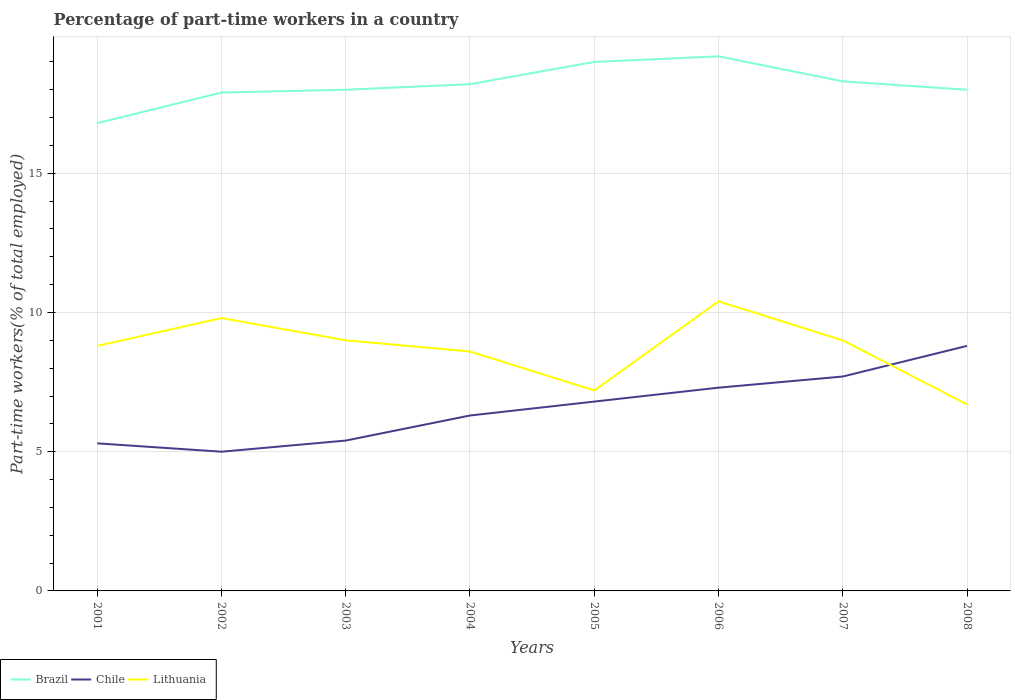Does the line corresponding to Lithuania intersect with the line corresponding to Brazil?
Make the answer very short. No. Is the number of lines equal to the number of legend labels?
Keep it short and to the point. Yes. What is the total percentage of part-time workers in Brazil in the graph?
Your answer should be very brief. 0.7. What is the difference between the highest and the second highest percentage of part-time workers in Chile?
Offer a very short reply. 3.8. What is the difference between the highest and the lowest percentage of part-time workers in Brazil?
Provide a short and direct response. 4. How many lines are there?
Provide a short and direct response. 3. How many years are there in the graph?
Your answer should be compact. 8. Are the values on the major ticks of Y-axis written in scientific E-notation?
Your answer should be very brief. No. Where does the legend appear in the graph?
Offer a terse response. Bottom left. How are the legend labels stacked?
Offer a very short reply. Horizontal. What is the title of the graph?
Offer a terse response. Percentage of part-time workers in a country. Does "Arab World" appear as one of the legend labels in the graph?
Your answer should be compact. No. What is the label or title of the Y-axis?
Your answer should be compact. Part-time workers(% of total employed). What is the Part-time workers(% of total employed) in Brazil in 2001?
Provide a succinct answer. 16.8. What is the Part-time workers(% of total employed) in Chile in 2001?
Make the answer very short. 5.3. What is the Part-time workers(% of total employed) of Lithuania in 2001?
Give a very brief answer. 8.8. What is the Part-time workers(% of total employed) of Brazil in 2002?
Keep it short and to the point. 17.9. What is the Part-time workers(% of total employed) in Lithuania in 2002?
Ensure brevity in your answer.  9.8. What is the Part-time workers(% of total employed) in Brazil in 2003?
Your answer should be compact. 18. What is the Part-time workers(% of total employed) in Chile in 2003?
Provide a short and direct response. 5.4. What is the Part-time workers(% of total employed) of Brazil in 2004?
Keep it short and to the point. 18.2. What is the Part-time workers(% of total employed) of Chile in 2004?
Make the answer very short. 6.3. What is the Part-time workers(% of total employed) of Lithuania in 2004?
Your response must be concise. 8.6. What is the Part-time workers(% of total employed) of Chile in 2005?
Make the answer very short. 6.8. What is the Part-time workers(% of total employed) of Lithuania in 2005?
Make the answer very short. 7.2. What is the Part-time workers(% of total employed) of Brazil in 2006?
Make the answer very short. 19.2. What is the Part-time workers(% of total employed) in Chile in 2006?
Your response must be concise. 7.3. What is the Part-time workers(% of total employed) of Lithuania in 2006?
Offer a terse response. 10.4. What is the Part-time workers(% of total employed) in Brazil in 2007?
Keep it short and to the point. 18.3. What is the Part-time workers(% of total employed) in Chile in 2007?
Offer a terse response. 7.7. What is the Part-time workers(% of total employed) of Chile in 2008?
Ensure brevity in your answer.  8.8. What is the Part-time workers(% of total employed) in Lithuania in 2008?
Provide a succinct answer. 6.7. Across all years, what is the maximum Part-time workers(% of total employed) of Brazil?
Provide a short and direct response. 19.2. Across all years, what is the maximum Part-time workers(% of total employed) in Chile?
Your answer should be very brief. 8.8. Across all years, what is the maximum Part-time workers(% of total employed) in Lithuania?
Provide a short and direct response. 10.4. Across all years, what is the minimum Part-time workers(% of total employed) of Brazil?
Keep it short and to the point. 16.8. Across all years, what is the minimum Part-time workers(% of total employed) in Lithuania?
Your answer should be very brief. 6.7. What is the total Part-time workers(% of total employed) of Brazil in the graph?
Your response must be concise. 145.4. What is the total Part-time workers(% of total employed) in Chile in the graph?
Your answer should be compact. 52.6. What is the total Part-time workers(% of total employed) in Lithuania in the graph?
Keep it short and to the point. 69.5. What is the difference between the Part-time workers(% of total employed) of Brazil in 2001 and that in 2002?
Offer a very short reply. -1.1. What is the difference between the Part-time workers(% of total employed) in Chile in 2001 and that in 2002?
Offer a terse response. 0.3. What is the difference between the Part-time workers(% of total employed) in Lithuania in 2001 and that in 2002?
Make the answer very short. -1. What is the difference between the Part-time workers(% of total employed) of Brazil in 2001 and that in 2003?
Ensure brevity in your answer.  -1.2. What is the difference between the Part-time workers(% of total employed) of Lithuania in 2001 and that in 2003?
Make the answer very short. -0.2. What is the difference between the Part-time workers(% of total employed) in Chile in 2001 and that in 2004?
Your response must be concise. -1. What is the difference between the Part-time workers(% of total employed) in Chile in 2001 and that in 2005?
Make the answer very short. -1.5. What is the difference between the Part-time workers(% of total employed) of Brazil in 2001 and that in 2007?
Your answer should be very brief. -1.5. What is the difference between the Part-time workers(% of total employed) of Chile in 2001 and that in 2007?
Your response must be concise. -2.4. What is the difference between the Part-time workers(% of total employed) of Lithuania in 2001 and that in 2007?
Provide a succinct answer. -0.2. What is the difference between the Part-time workers(% of total employed) in Brazil in 2001 and that in 2008?
Your answer should be compact. -1.2. What is the difference between the Part-time workers(% of total employed) in Chile in 2001 and that in 2008?
Offer a terse response. -3.5. What is the difference between the Part-time workers(% of total employed) of Brazil in 2002 and that in 2003?
Your answer should be very brief. -0.1. What is the difference between the Part-time workers(% of total employed) of Chile in 2002 and that in 2003?
Your response must be concise. -0.4. What is the difference between the Part-time workers(% of total employed) in Brazil in 2002 and that in 2004?
Ensure brevity in your answer.  -0.3. What is the difference between the Part-time workers(% of total employed) of Chile in 2002 and that in 2004?
Keep it short and to the point. -1.3. What is the difference between the Part-time workers(% of total employed) in Lithuania in 2002 and that in 2005?
Your response must be concise. 2.6. What is the difference between the Part-time workers(% of total employed) in Lithuania in 2002 and that in 2006?
Provide a succinct answer. -0.6. What is the difference between the Part-time workers(% of total employed) in Brazil in 2002 and that in 2007?
Offer a very short reply. -0.4. What is the difference between the Part-time workers(% of total employed) in Chile in 2002 and that in 2007?
Offer a very short reply. -2.7. What is the difference between the Part-time workers(% of total employed) in Chile in 2002 and that in 2008?
Keep it short and to the point. -3.8. What is the difference between the Part-time workers(% of total employed) of Chile in 2003 and that in 2005?
Ensure brevity in your answer.  -1.4. What is the difference between the Part-time workers(% of total employed) in Brazil in 2003 and that in 2006?
Provide a succinct answer. -1.2. What is the difference between the Part-time workers(% of total employed) in Chile in 2003 and that in 2006?
Keep it short and to the point. -1.9. What is the difference between the Part-time workers(% of total employed) in Lithuania in 2003 and that in 2006?
Ensure brevity in your answer.  -1.4. What is the difference between the Part-time workers(% of total employed) in Lithuania in 2003 and that in 2007?
Your answer should be compact. 0. What is the difference between the Part-time workers(% of total employed) in Brazil in 2003 and that in 2008?
Offer a very short reply. 0. What is the difference between the Part-time workers(% of total employed) in Brazil in 2004 and that in 2005?
Provide a short and direct response. -0.8. What is the difference between the Part-time workers(% of total employed) in Chile in 2004 and that in 2005?
Provide a succinct answer. -0.5. What is the difference between the Part-time workers(% of total employed) of Lithuania in 2004 and that in 2006?
Offer a very short reply. -1.8. What is the difference between the Part-time workers(% of total employed) of Chile in 2004 and that in 2007?
Your response must be concise. -1.4. What is the difference between the Part-time workers(% of total employed) in Brazil in 2004 and that in 2008?
Your answer should be compact. 0.2. What is the difference between the Part-time workers(% of total employed) in Chile in 2005 and that in 2006?
Offer a very short reply. -0.5. What is the difference between the Part-time workers(% of total employed) in Lithuania in 2005 and that in 2006?
Your response must be concise. -3.2. What is the difference between the Part-time workers(% of total employed) in Lithuania in 2005 and that in 2007?
Offer a terse response. -1.8. What is the difference between the Part-time workers(% of total employed) in Brazil in 2005 and that in 2008?
Provide a short and direct response. 1. What is the difference between the Part-time workers(% of total employed) of Chile in 2005 and that in 2008?
Offer a terse response. -2. What is the difference between the Part-time workers(% of total employed) in Lithuania in 2006 and that in 2007?
Offer a very short reply. 1.4. What is the difference between the Part-time workers(% of total employed) of Brazil in 2001 and the Part-time workers(% of total employed) of Lithuania in 2002?
Ensure brevity in your answer.  7. What is the difference between the Part-time workers(% of total employed) of Chile in 2001 and the Part-time workers(% of total employed) of Lithuania in 2002?
Make the answer very short. -4.5. What is the difference between the Part-time workers(% of total employed) in Brazil in 2001 and the Part-time workers(% of total employed) in Chile in 2004?
Offer a terse response. 10.5. What is the difference between the Part-time workers(% of total employed) in Brazil in 2001 and the Part-time workers(% of total employed) in Lithuania in 2004?
Keep it short and to the point. 8.2. What is the difference between the Part-time workers(% of total employed) of Chile in 2001 and the Part-time workers(% of total employed) of Lithuania in 2004?
Make the answer very short. -3.3. What is the difference between the Part-time workers(% of total employed) in Brazil in 2001 and the Part-time workers(% of total employed) in Chile in 2005?
Your answer should be very brief. 10. What is the difference between the Part-time workers(% of total employed) of Brazil in 2001 and the Part-time workers(% of total employed) of Lithuania in 2005?
Provide a succinct answer. 9.6. What is the difference between the Part-time workers(% of total employed) of Brazil in 2001 and the Part-time workers(% of total employed) of Chile in 2006?
Provide a succinct answer. 9.5. What is the difference between the Part-time workers(% of total employed) of Chile in 2001 and the Part-time workers(% of total employed) of Lithuania in 2006?
Your answer should be compact. -5.1. What is the difference between the Part-time workers(% of total employed) in Chile in 2001 and the Part-time workers(% of total employed) in Lithuania in 2008?
Offer a very short reply. -1.4. What is the difference between the Part-time workers(% of total employed) of Brazil in 2002 and the Part-time workers(% of total employed) of Chile in 2003?
Offer a very short reply. 12.5. What is the difference between the Part-time workers(% of total employed) of Brazil in 2002 and the Part-time workers(% of total employed) of Chile in 2004?
Your response must be concise. 11.6. What is the difference between the Part-time workers(% of total employed) of Chile in 2002 and the Part-time workers(% of total employed) of Lithuania in 2004?
Your response must be concise. -3.6. What is the difference between the Part-time workers(% of total employed) of Brazil in 2002 and the Part-time workers(% of total employed) of Chile in 2005?
Provide a succinct answer. 11.1. What is the difference between the Part-time workers(% of total employed) in Brazil in 2002 and the Part-time workers(% of total employed) in Lithuania in 2005?
Offer a terse response. 10.7. What is the difference between the Part-time workers(% of total employed) in Brazil in 2002 and the Part-time workers(% of total employed) in Chile in 2007?
Make the answer very short. 10.2. What is the difference between the Part-time workers(% of total employed) of Brazil in 2002 and the Part-time workers(% of total employed) of Lithuania in 2008?
Offer a very short reply. 11.2. What is the difference between the Part-time workers(% of total employed) in Brazil in 2003 and the Part-time workers(% of total employed) in Chile in 2004?
Offer a very short reply. 11.7. What is the difference between the Part-time workers(% of total employed) in Chile in 2003 and the Part-time workers(% of total employed) in Lithuania in 2004?
Your answer should be compact. -3.2. What is the difference between the Part-time workers(% of total employed) in Brazil in 2003 and the Part-time workers(% of total employed) in Lithuania in 2006?
Provide a succinct answer. 7.6. What is the difference between the Part-time workers(% of total employed) of Chile in 2003 and the Part-time workers(% of total employed) of Lithuania in 2006?
Provide a short and direct response. -5. What is the difference between the Part-time workers(% of total employed) of Brazil in 2003 and the Part-time workers(% of total employed) of Chile in 2007?
Make the answer very short. 10.3. What is the difference between the Part-time workers(% of total employed) of Brazil in 2003 and the Part-time workers(% of total employed) of Lithuania in 2007?
Your response must be concise. 9. What is the difference between the Part-time workers(% of total employed) of Chile in 2003 and the Part-time workers(% of total employed) of Lithuania in 2007?
Keep it short and to the point. -3.6. What is the difference between the Part-time workers(% of total employed) in Brazil in 2003 and the Part-time workers(% of total employed) in Chile in 2008?
Keep it short and to the point. 9.2. What is the difference between the Part-time workers(% of total employed) of Brazil in 2003 and the Part-time workers(% of total employed) of Lithuania in 2008?
Make the answer very short. 11.3. What is the difference between the Part-time workers(% of total employed) in Chile in 2003 and the Part-time workers(% of total employed) in Lithuania in 2008?
Keep it short and to the point. -1.3. What is the difference between the Part-time workers(% of total employed) in Brazil in 2004 and the Part-time workers(% of total employed) in Lithuania in 2005?
Give a very brief answer. 11. What is the difference between the Part-time workers(% of total employed) in Chile in 2004 and the Part-time workers(% of total employed) in Lithuania in 2005?
Offer a terse response. -0.9. What is the difference between the Part-time workers(% of total employed) in Brazil in 2004 and the Part-time workers(% of total employed) in Lithuania in 2006?
Your answer should be compact. 7.8. What is the difference between the Part-time workers(% of total employed) of Chile in 2004 and the Part-time workers(% of total employed) of Lithuania in 2006?
Provide a short and direct response. -4.1. What is the difference between the Part-time workers(% of total employed) of Brazil in 2004 and the Part-time workers(% of total employed) of Chile in 2007?
Offer a terse response. 10.5. What is the difference between the Part-time workers(% of total employed) in Brazil in 2004 and the Part-time workers(% of total employed) in Lithuania in 2007?
Offer a terse response. 9.2. What is the difference between the Part-time workers(% of total employed) of Brazil in 2004 and the Part-time workers(% of total employed) of Chile in 2008?
Your answer should be very brief. 9.4. What is the difference between the Part-time workers(% of total employed) in Brazil in 2005 and the Part-time workers(% of total employed) in Chile in 2006?
Offer a very short reply. 11.7. What is the difference between the Part-time workers(% of total employed) in Brazil in 2005 and the Part-time workers(% of total employed) in Lithuania in 2006?
Provide a short and direct response. 8.6. What is the difference between the Part-time workers(% of total employed) of Brazil in 2005 and the Part-time workers(% of total employed) of Lithuania in 2007?
Give a very brief answer. 10. What is the difference between the Part-time workers(% of total employed) of Brazil in 2005 and the Part-time workers(% of total employed) of Chile in 2008?
Your answer should be compact. 10.2. What is the difference between the Part-time workers(% of total employed) in Brazil in 2005 and the Part-time workers(% of total employed) in Lithuania in 2008?
Your response must be concise. 12.3. What is the difference between the Part-time workers(% of total employed) of Chile in 2005 and the Part-time workers(% of total employed) of Lithuania in 2008?
Your answer should be very brief. 0.1. What is the difference between the Part-time workers(% of total employed) in Chile in 2006 and the Part-time workers(% of total employed) in Lithuania in 2008?
Ensure brevity in your answer.  0.6. What is the difference between the Part-time workers(% of total employed) in Brazil in 2007 and the Part-time workers(% of total employed) in Chile in 2008?
Your answer should be compact. 9.5. What is the average Part-time workers(% of total employed) of Brazil per year?
Make the answer very short. 18.18. What is the average Part-time workers(% of total employed) in Chile per year?
Offer a very short reply. 6.58. What is the average Part-time workers(% of total employed) of Lithuania per year?
Offer a terse response. 8.69. In the year 2002, what is the difference between the Part-time workers(% of total employed) in Brazil and Part-time workers(% of total employed) in Chile?
Offer a terse response. 12.9. In the year 2002, what is the difference between the Part-time workers(% of total employed) of Brazil and Part-time workers(% of total employed) of Lithuania?
Provide a short and direct response. 8.1. In the year 2003, what is the difference between the Part-time workers(% of total employed) in Brazil and Part-time workers(% of total employed) in Chile?
Your answer should be very brief. 12.6. In the year 2003, what is the difference between the Part-time workers(% of total employed) in Brazil and Part-time workers(% of total employed) in Lithuania?
Your response must be concise. 9. In the year 2004, what is the difference between the Part-time workers(% of total employed) in Brazil and Part-time workers(% of total employed) in Chile?
Your answer should be compact. 11.9. In the year 2005, what is the difference between the Part-time workers(% of total employed) of Brazil and Part-time workers(% of total employed) of Chile?
Provide a succinct answer. 12.2. In the year 2006, what is the difference between the Part-time workers(% of total employed) of Brazil and Part-time workers(% of total employed) of Chile?
Offer a very short reply. 11.9. In the year 2007, what is the difference between the Part-time workers(% of total employed) of Chile and Part-time workers(% of total employed) of Lithuania?
Your response must be concise. -1.3. In the year 2008, what is the difference between the Part-time workers(% of total employed) of Brazil and Part-time workers(% of total employed) of Chile?
Make the answer very short. 9.2. What is the ratio of the Part-time workers(% of total employed) in Brazil in 2001 to that in 2002?
Provide a succinct answer. 0.94. What is the ratio of the Part-time workers(% of total employed) in Chile in 2001 to that in 2002?
Your answer should be very brief. 1.06. What is the ratio of the Part-time workers(% of total employed) in Lithuania in 2001 to that in 2002?
Ensure brevity in your answer.  0.9. What is the ratio of the Part-time workers(% of total employed) in Chile in 2001 to that in 2003?
Provide a succinct answer. 0.98. What is the ratio of the Part-time workers(% of total employed) of Lithuania in 2001 to that in 2003?
Provide a short and direct response. 0.98. What is the ratio of the Part-time workers(% of total employed) in Chile in 2001 to that in 2004?
Make the answer very short. 0.84. What is the ratio of the Part-time workers(% of total employed) in Lithuania in 2001 to that in 2004?
Keep it short and to the point. 1.02. What is the ratio of the Part-time workers(% of total employed) of Brazil in 2001 to that in 2005?
Provide a short and direct response. 0.88. What is the ratio of the Part-time workers(% of total employed) of Chile in 2001 to that in 2005?
Give a very brief answer. 0.78. What is the ratio of the Part-time workers(% of total employed) in Lithuania in 2001 to that in 2005?
Give a very brief answer. 1.22. What is the ratio of the Part-time workers(% of total employed) of Chile in 2001 to that in 2006?
Your response must be concise. 0.73. What is the ratio of the Part-time workers(% of total employed) of Lithuania in 2001 to that in 2006?
Make the answer very short. 0.85. What is the ratio of the Part-time workers(% of total employed) in Brazil in 2001 to that in 2007?
Make the answer very short. 0.92. What is the ratio of the Part-time workers(% of total employed) in Chile in 2001 to that in 2007?
Offer a terse response. 0.69. What is the ratio of the Part-time workers(% of total employed) of Lithuania in 2001 to that in 2007?
Provide a short and direct response. 0.98. What is the ratio of the Part-time workers(% of total employed) of Chile in 2001 to that in 2008?
Make the answer very short. 0.6. What is the ratio of the Part-time workers(% of total employed) of Lithuania in 2001 to that in 2008?
Ensure brevity in your answer.  1.31. What is the ratio of the Part-time workers(% of total employed) in Brazil in 2002 to that in 2003?
Make the answer very short. 0.99. What is the ratio of the Part-time workers(% of total employed) of Chile in 2002 to that in 2003?
Offer a terse response. 0.93. What is the ratio of the Part-time workers(% of total employed) in Lithuania in 2002 to that in 2003?
Make the answer very short. 1.09. What is the ratio of the Part-time workers(% of total employed) in Brazil in 2002 to that in 2004?
Keep it short and to the point. 0.98. What is the ratio of the Part-time workers(% of total employed) in Chile in 2002 to that in 2004?
Keep it short and to the point. 0.79. What is the ratio of the Part-time workers(% of total employed) of Lithuania in 2002 to that in 2004?
Ensure brevity in your answer.  1.14. What is the ratio of the Part-time workers(% of total employed) of Brazil in 2002 to that in 2005?
Provide a succinct answer. 0.94. What is the ratio of the Part-time workers(% of total employed) of Chile in 2002 to that in 2005?
Make the answer very short. 0.74. What is the ratio of the Part-time workers(% of total employed) in Lithuania in 2002 to that in 2005?
Offer a very short reply. 1.36. What is the ratio of the Part-time workers(% of total employed) in Brazil in 2002 to that in 2006?
Keep it short and to the point. 0.93. What is the ratio of the Part-time workers(% of total employed) of Chile in 2002 to that in 2006?
Your answer should be very brief. 0.68. What is the ratio of the Part-time workers(% of total employed) of Lithuania in 2002 to that in 2006?
Offer a terse response. 0.94. What is the ratio of the Part-time workers(% of total employed) in Brazil in 2002 to that in 2007?
Provide a succinct answer. 0.98. What is the ratio of the Part-time workers(% of total employed) in Chile in 2002 to that in 2007?
Your response must be concise. 0.65. What is the ratio of the Part-time workers(% of total employed) in Lithuania in 2002 to that in 2007?
Your answer should be compact. 1.09. What is the ratio of the Part-time workers(% of total employed) in Brazil in 2002 to that in 2008?
Your response must be concise. 0.99. What is the ratio of the Part-time workers(% of total employed) in Chile in 2002 to that in 2008?
Provide a succinct answer. 0.57. What is the ratio of the Part-time workers(% of total employed) of Lithuania in 2002 to that in 2008?
Keep it short and to the point. 1.46. What is the ratio of the Part-time workers(% of total employed) of Brazil in 2003 to that in 2004?
Give a very brief answer. 0.99. What is the ratio of the Part-time workers(% of total employed) of Lithuania in 2003 to that in 2004?
Your answer should be very brief. 1.05. What is the ratio of the Part-time workers(% of total employed) in Brazil in 2003 to that in 2005?
Ensure brevity in your answer.  0.95. What is the ratio of the Part-time workers(% of total employed) in Chile in 2003 to that in 2005?
Provide a succinct answer. 0.79. What is the ratio of the Part-time workers(% of total employed) in Lithuania in 2003 to that in 2005?
Provide a short and direct response. 1.25. What is the ratio of the Part-time workers(% of total employed) of Chile in 2003 to that in 2006?
Your answer should be very brief. 0.74. What is the ratio of the Part-time workers(% of total employed) in Lithuania in 2003 to that in 2006?
Keep it short and to the point. 0.87. What is the ratio of the Part-time workers(% of total employed) of Brazil in 2003 to that in 2007?
Offer a very short reply. 0.98. What is the ratio of the Part-time workers(% of total employed) of Chile in 2003 to that in 2007?
Ensure brevity in your answer.  0.7. What is the ratio of the Part-time workers(% of total employed) in Brazil in 2003 to that in 2008?
Your response must be concise. 1. What is the ratio of the Part-time workers(% of total employed) in Chile in 2003 to that in 2008?
Offer a very short reply. 0.61. What is the ratio of the Part-time workers(% of total employed) in Lithuania in 2003 to that in 2008?
Offer a terse response. 1.34. What is the ratio of the Part-time workers(% of total employed) of Brazil in 2004 to that in 2005?
Keep it short and to the point. 0.96. What is the ratio of the Part-time workers(% of total employed) of Chile in 2004 to that in 2005?
Keep it short and to the point. 0.93. What is the ratio of the Part-time workers(% of total employed) in Lithuania in 2004 to that in 2005?
Your answer should be compact. 1.19. What is the ratio of the Part-time workers(% of total employed) in Brazil in 2004 to that in 2006?
Your answer should be compact. 0.95. What is the ratio of the Part-time workers(% of total employed) in Chile in 2004 to that in 2006?
Ensure brevity in your answer.  0.86. What is the ratio of the Part-time workers(% of total employed) in Lithuania in 2004 to that in 2006?
Keep it short and to the point. 0.83. What is the ratio of the Part-time workers(% of total employed) of Chile in 2004 to that in 2007?
Offer a terse response. 0.82. What is the ratio of the Part-time workers(% of total employed) in Lithuania in 2004 to that in 2007?
Offer a terse response. 0.96. What is the ratio of the Part-time workers(% of total employed) in Brazil in 2004 to that in 2008?
Ensure brevity in your answer.  1.01. What is the ratio of the Part-time workers(% of total employed) in Chile in 2004 to that in 2008?
Provide a succinct answer. 0.72. What is the ratio of the Part-time workers(% of total employed) of Lithuania in 2004 to that in 2008?
Provide a short and direct response. 1.28. What is the ratio of the Part-time workers(% of total employed) of Brazil in 2005 to that in 2006?
Keep it short and to the point. 0.99. What is the ratio of the Part-time workers(% of total employed) in Chile in 2005 to that in 2006?
Offer a very short reply. 0.93. What is the ratio of the Part-time workers(% of total employed) of Lithuania in 2005 to that in 2006?
Provide a succinct answer. 0.69. What is the ratio of the Part-time workers(% of total employed) of Brazil in 2005 to that in 2007?
Your response must be concise. 1.04. What is the ratio of the Part-time workers(% of total employed) in Chile in 2005 to that in 2007?
Your answer should be compact. 0.88. What is the ratio of the Part-time workers(% of total employed) in Lithuania in 2005 to that in 2007?
Keep it short and to the point. 0.8. What is the ratio of the Part-time workers(% of total employed) of Brazil in 2005 to that in 2008?
Provide a short and direct response. 1.06. What is the ratio of the Part-time workers(% of total employed) in Chile in 2005 to that in 2008?
Make the answer very short. 0.77. What is the ratio of the Part-time workers(% of total employed) of Lithuania in 2005 to that in 2008?
Keep it short and to the point. 1.07. What is the ratio of the Part-time workers(% of total employed) of Brazil in 2006 to that in 2007?
Ensure brevity in your answer.  1.05. What is the ratio of the Part-time workers(% of total employed) in Chile in 2006 to that in 2007?
Ensure brevity in your answer.  0.95. What is the ratio of the Part-time workers(% of total employed) in Lithuania in 2006 to that in 2007?
Keep it short and to the point. 1.16. What is the ratio of the Part-time workers(% of total employed) in Brazil in 2006 to that in 2008?
Your answer should be compact. 1.07. What is the ratio of the Part-time workers(% of total employed) in Chile in 2006 to that in 2008?
Offer a very short reply. 0.83. What is the ratio of the Part-time workers(% of total employed) of Lithuania in 2006 to that in 2008?
Provide a short and direct response. 1.55. What is the ratio of the Part-time workers(% of total employed) of Brazil in 2007 to that in 2008?
Your response must be concise. 1.02. What is the ratio of the Part-time workers(% of total employed) in Chile in 2007 to that in 2008?
Make the answer very short. 0.88. What is the ratio of the Part-time workers(% of total employed) in Lithuania in 2007 to that in 2008?
Provide a short and direct response. 1.34. What is the difference between the highest and the lowest Part-time workers(% of total employed) of Chile?
Offer a terse response. 3.8. 